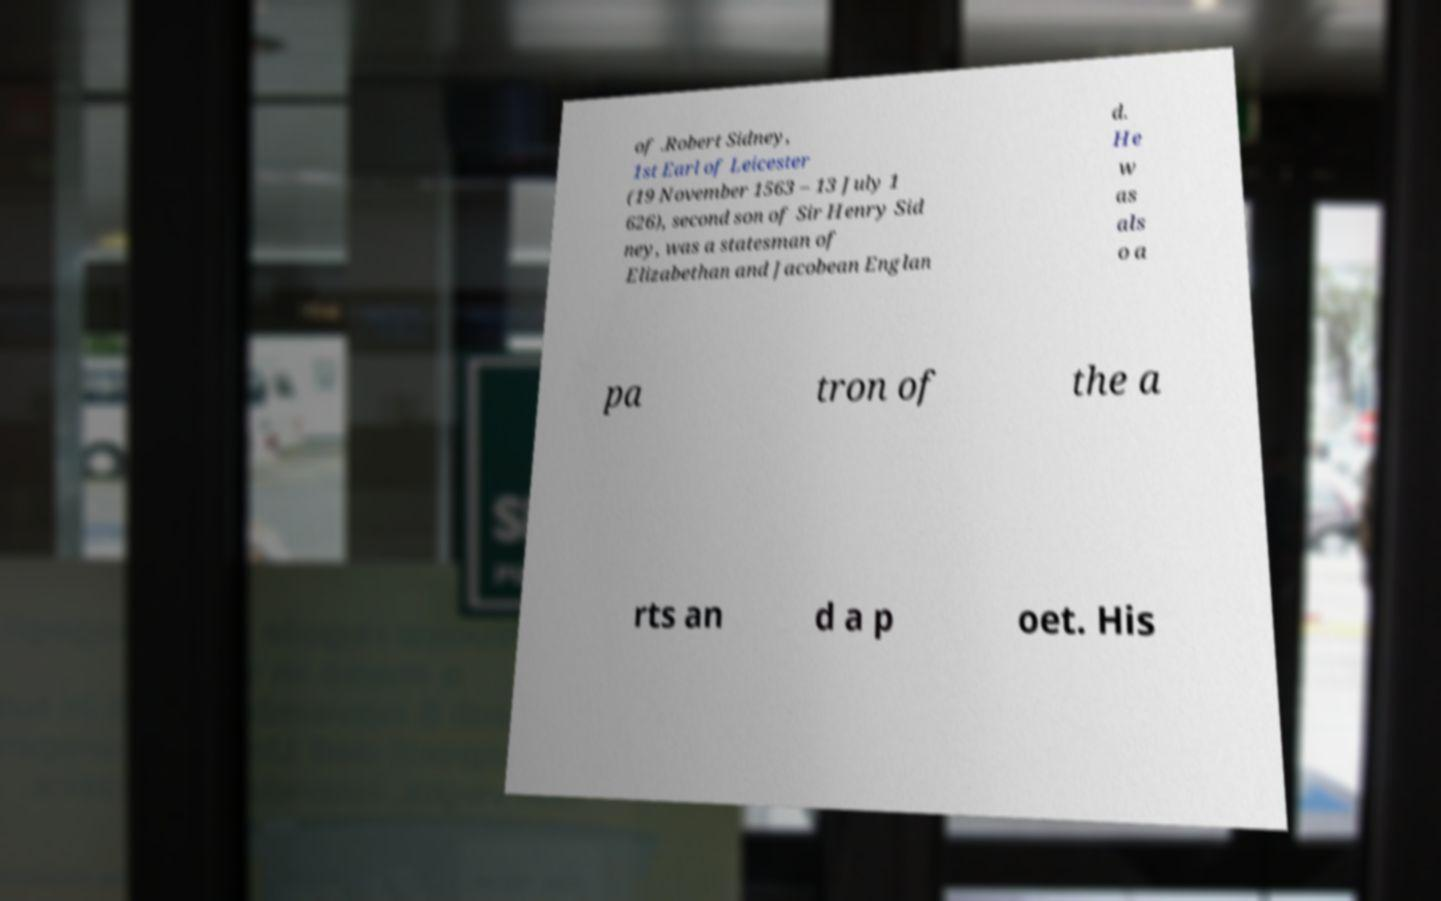Could you assist in decoding the text presented in this image and type it out clearly? of .Robert Sidney, 1st Earl of Leicester (19 November 1563 – 13 July 1 626), second son of Sir Henry Sid ney, was a statesman of Elizabethan and Jacobean Englan d. He w as als o a pa tron of the a rts an d a p oet. His 